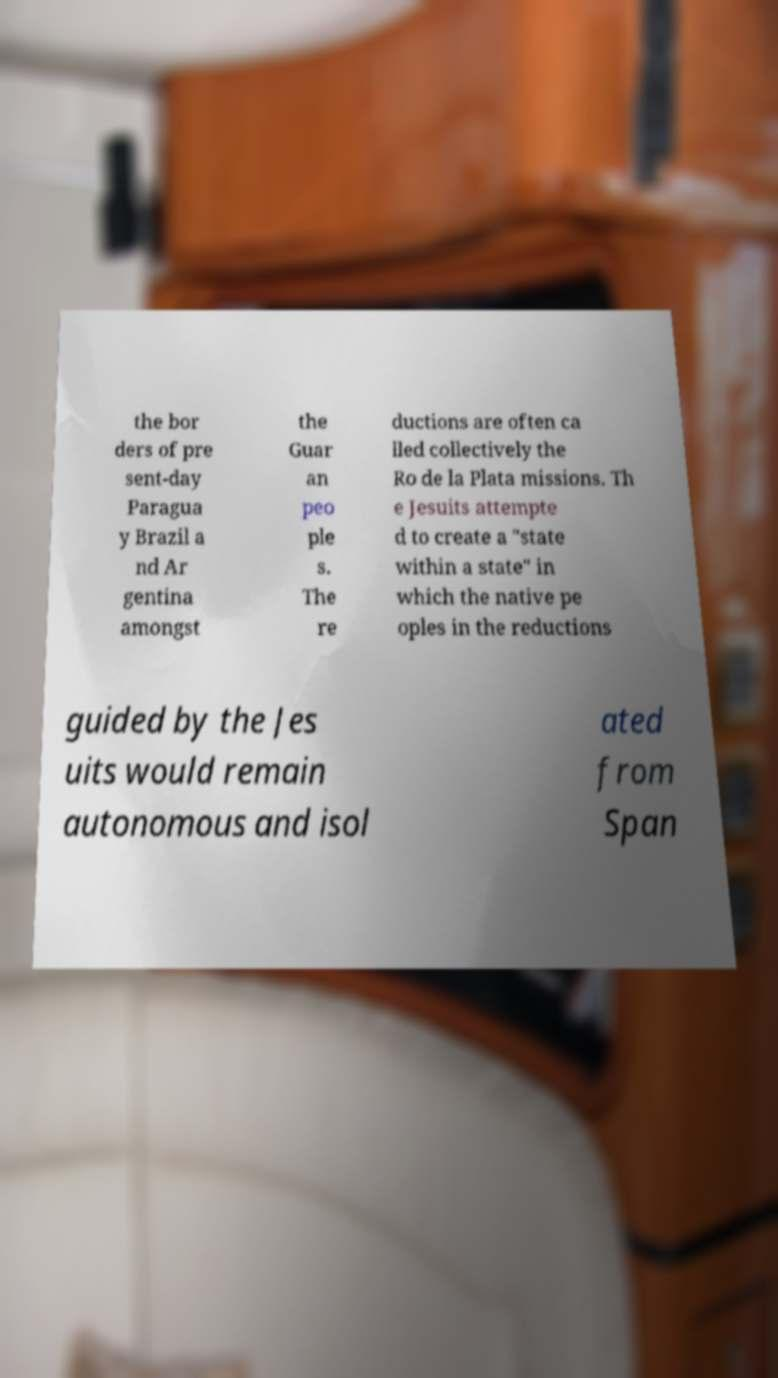For documentation purposes, I need the text within this image transcribed. Could you provide that? the bor ders of pre sent-day Paragua y Brazil a nd Ar gentina amongst the Guar an peo ple s. The re ductions are often ca lled collectively the Ro de la Plata missions. Th e Jesuits attempte d to create a "state within a state" in which the native pe oples in the reductions guided by the Jes uits would remain autonomous and isol ated from Span 